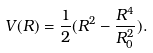<formula> <loc_0><loc_0><loc_500><loc_500>V ( R ) = \frac { 1 } { 2 } ( R ^ { 2 } - \frac { R ^ { 4 } } { R _ { 0 } ^ { 2 } } ) .</formula> 